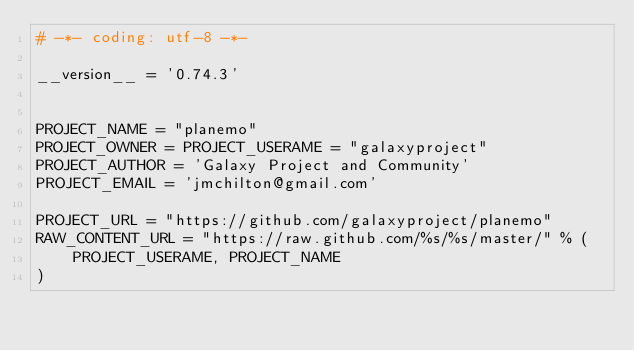Convert code to text. <code><loc_0><loc_0><loc_500><loc_500><_Python_># -*- coding: utf-8 -*-

__version__ = '0.74.3'


PROJECT_NAME = "planemo"
PROJECT_OWNER = PROJECT_USERAME = "galaxyproject"
PROJECT_AUTHOR = 'Galaxy Project and Community'
PROJECT_EMAIL = 'jmchilton@gmail.com'

PROJECT_URL = "https://github.com/galaxyproject/planemo"
RAW_CONTENT_URL = "https://raw.github.com/%s/%s/master/" % (
    PROJECT_USERAME, PROJECT_NAME
)
</code> 